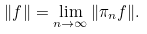<formula> <loc_0><loc_0><loc_500><loc_500>\| f \| = \lim _ { n \to \infty } \| \pi _ { n } f \| .</formula> 